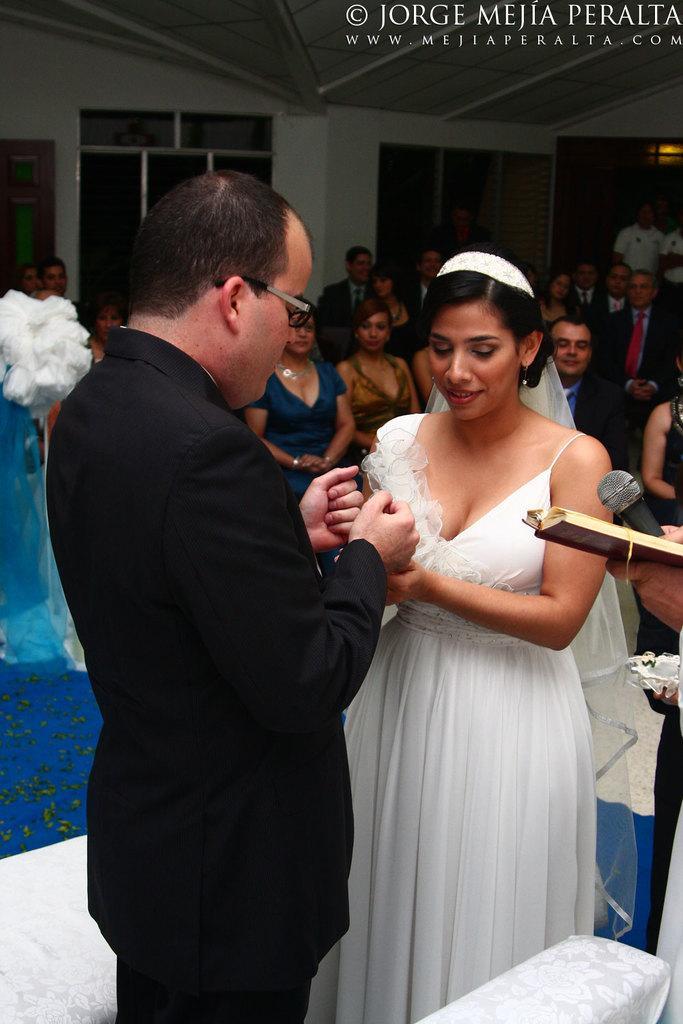Please provide a concise description of this image. In the center of the image, we can see people and on the right, there is a person standing and holding a mic and a book. In the background, there are some other people and we can see a lights, windows and some text and some other things. 